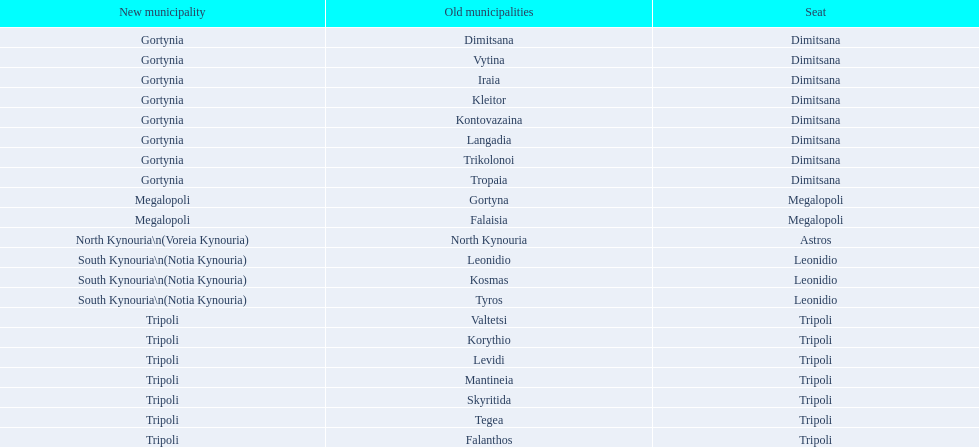When arcadia was reformed in 2011, how many municipalities were created? 5. 